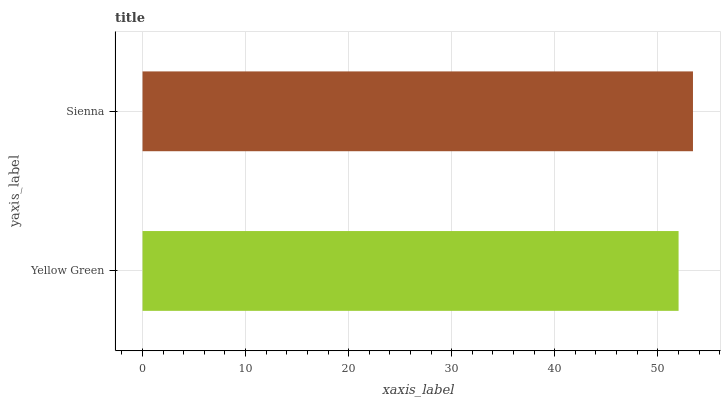Is Yellow Green the minimum?
Answer yes or no. Yes. Is Sienna the maximum?
Answer yes or no. Yes. Is Sienna the minimum?
Answer yes or no. No. Is Sienna greater than Yellow Green?
Answer yes or no. Yes. Is Yellow Green less than Sienna?
Answer yes or no. Yes. Is Yellow Green greater than Sienna?
Answer yes or no. No. Is Sienna less than Yellow Green?
Answer yes or no. No. Is Sienna the high median?
Answer yes or no. Yes. Is Yellow Green the low median?
Answer yes or no. Yes. Is Yellow Green the high median?
Answer yes or no. No. Is Sienna the low median?
Answer yes or no. No. 